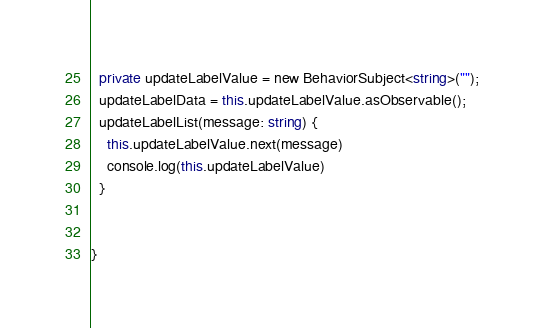<code> <loc_0><loc_0><loc_500><loc_500><_TypeScript_>  private updateLabelValue = new BehaviorSubject<string>("");
  updateLabelData = this.updateLabelValue.asObservable();
  updateLabelList(message: string) {
    this.updateLabelValue.next(message)
    console.log(this.updateLabelValue)
  }


}
</code> 